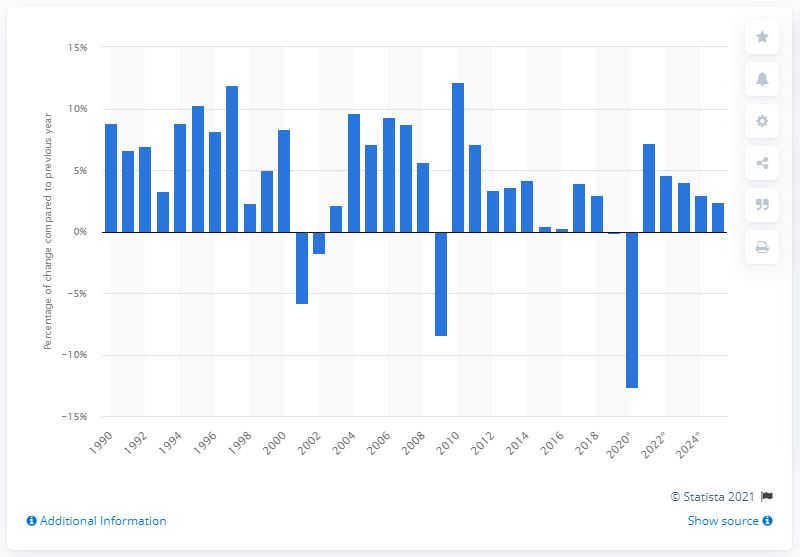Point out several critical features in this image. In 1990, the United States began to experience changes in the exports of trade goods and services. 